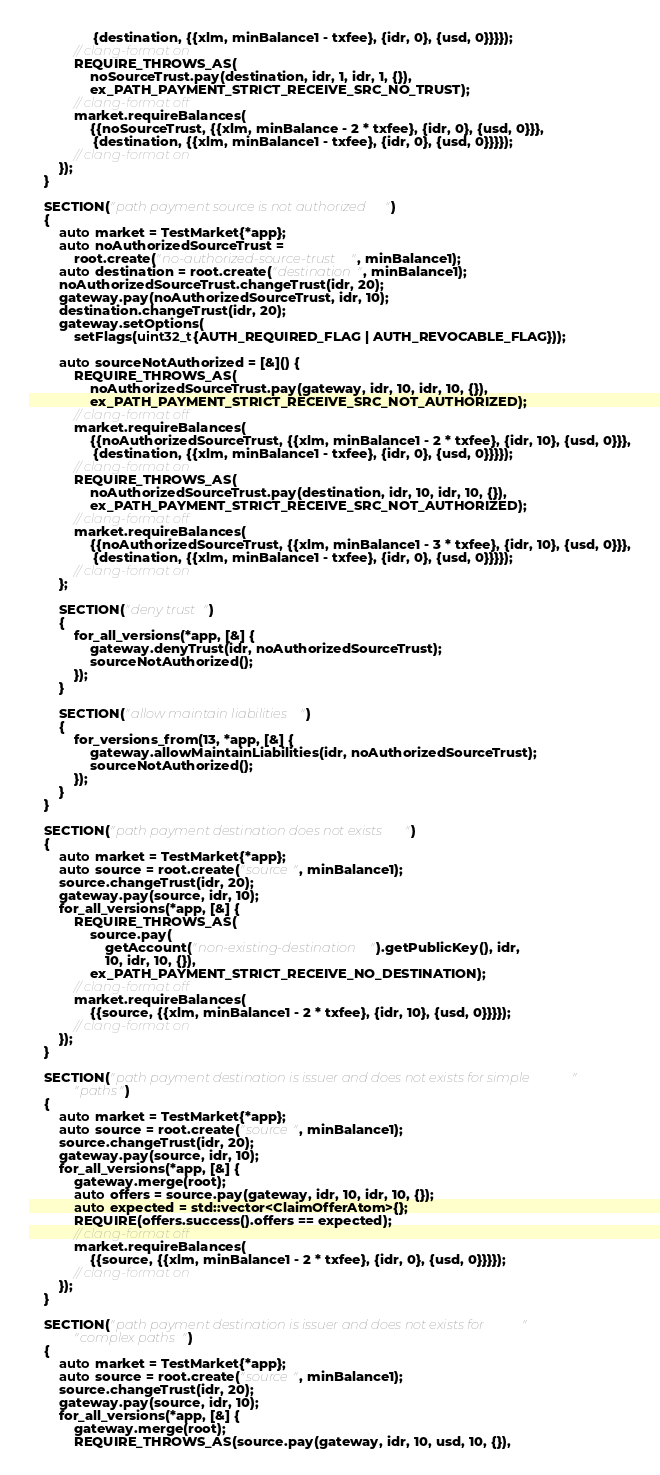<code> <loc_0><loc_0><loc_500><loc_500><_C++_>                 {destination, {{xlm, minBalance1 - txfee}, {idr, 0}, {usd, 0}}}});
            // clang-format on
            REQUIRE_THROWS_AS(
                noSourceTrust.pay(destination, idr, 1, idr, 1, {}),
                ex_PATH_PAYMENT_STRICT_RECEIVE_SRC_NO_TRUST);
            // clang-format off
            market.requireBalances(
                {{noSourceTrust, {{xlm, minBalance - 2 * txfee}, {idr, 0}, {usd, 0}}},
                 {destination, {{xlm, minBalance1 - txfee}, {idr, 0}, {usd, 0}}}});
            // clang-format on
        });
    }

    SECTION("path payment source is not authorized")
    {
        auto market = TestMarket{*app};
        auto noAuthorizedSourceTrust =
            root.create("no-authorized-source-trust", minBalance1);
        auto destination = root.create("destination", minBalance1);
        noAuthorizedSourceTrust.changeTrust(idr, 20);
        gateway.pay(noAuthorizedSourceTrust, idr, 10);
        destination.changeTrust(idr, 20);
        gateway.setOptions(
            setFlags(uint32_t{AUTH_REQUIRED_FLAG | AUTH_REVOCABLE_FLAG}));

        auto sourceNotAuthorized = [&]() {
            REQUIRE_THROWS_AS(
                noAuthorizedSourceTrust.pay(gateway, idr, 10, idr, 10, {}),
                ex_PATH_PAYMENT_STRICT_RECEIVE_SRC_NOT_AUTHORIZED);
            // clang-format off
            market.requireBalances(
                {{noAuthorizedSourceTrust, {{xlm, minBalance1 - 2 * txfee}, {idr, 10}, {usd, 0}}},
                 {destination, {{xlm, minBalance1 - txfee}, {idr, 0}, {usd, 0}}}});
            // clang-format on
            REQUIRE_THROWS_AS(
                noAuthorizedSourceTrust.pay(destination, idr, 10, idr, 10, {}),
                ex_PATH_PAYMENT_STRICT_RECEIVE_SRC_NOT_AUTHORIZED);
            // clang-format off
            market.requireBalances(
                {{noAuthorizedSourceTrust, {{xlm, minBalance1 - 3 * txfee}, {idr, 10}, {usd, 0}}},
                 {destination, {{xlm, minBalance1 - txfee}, {idr, 0}, {usd, 0}}}});
            // clang-format on
        };

        SECTION("deny trust")
        {
            for_all_versions(*app, [&] {
                gateway.denyTrust(idr, noAuthorizedSourceTrust);
                sourceNotAuthorized();
            });
        }

        SECTION("allow maintain liabilities")
        {
            for_versions_from(13, *app, [&] {
                gateway.allowMaintainLiabilities(idr, noAuthorizedSourceTrust);
                sourceNotAuthorized();
            });
        }
    }

    SECTION("path payment destination does not exists")
    {
        auto market = TestMarket{*app};
        auto source = root.create("source", minBalance1);
        source.changeTrust(idr, 20);
        gateway.pay(source, idr, 10);
        for_all_versions(*app, [&] {
            REQUIRE_THROWS_AS(
                source.pay(
                    getAccount("non-existing-destination").getPublicKey(), idr,
                    10, idr, 10, {}),
                ex_PATH_PAYMENT_STRICT_RECEIVE_NO_DESTINATION);
            // clang-format off
            market.requireBalances(
                {{source, {{xlm, minBalance1 - 2 * txfee}, {idr, 10}, {usd, 0}}}});
            // clang-format on
        });
    }

    SECTION("path payment destination is issuer and does not exists for simple "
            "paths")
    {
        auto market = TestMarket{*app};
        auto source = root.create("source", minBalance1);
        source.changeTrust(idr, 20);
        gateway.pay(source, idr, 10);
        for_all_versions(*app, [&] {
            gateway.merge(root);
            auto offers = source.pay(gateway, idr, 10, idr, 10, {});
            auto expected = std::vector<ClaimOfferAtom>{};
            REQUIRE(offers.success().offers == expected);
            // clang-format off
            market.requireBalances(
                {{source, {{xlm, minBalance1 - 2 * txfee}, {idr, 0}, {usd, 0}}}});
            // clang-format on
        });
    }

    SECTION("path payment destination is issuer and does not exists for "
            "complex paths")
    {
        auto market = TestMarket{*app};
        auto source = root.create("source", minBalance1);
        source.changeTrust(idr, 20);
        gateway.pay(source, idr, 10);
        for_all_versions(*app, [&] {
            gateway.merge(root);
            REQUIRE_THROWS_AS(source.pay(gateway, idr, 10, usd, 10, {}),</code> 